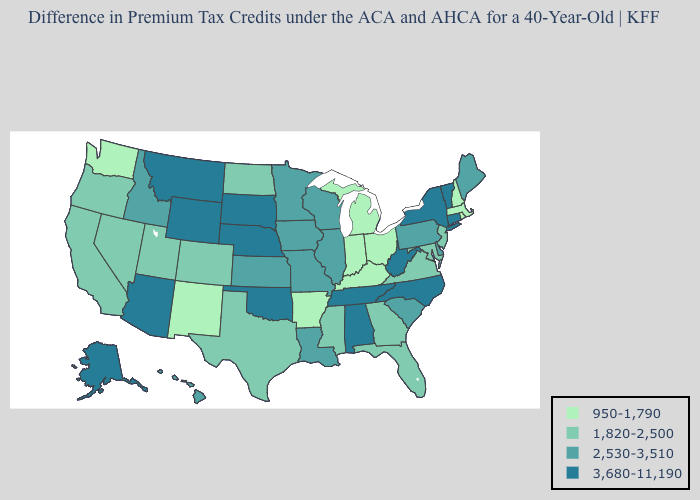Does the map have missing data?
Short answer required. No. What is the lowest value in states that border Maryland?
Give a very brief answer. 1,820-2,500. What is the value of South Carolina?
Answer briefly. 2,530-3,510. Does Iowa have a higher value than South Dakota?
Give a very brief answer. No. Does Rhode Island have the lowest value in the Northeast?
Be succinct. Yes. What is the value of Arizona?
Keep it brief. 3,680-11,190. Does Maryland have the lowest value in the USA?
Be succinct. No. What is the highest value in the USA?
Quick response, please. 3,680-11,190. Name the states that have a value in the range 3,680-11,190?
Concise answer only. Alabama, Alaska, Arizona, Connecticut, Montana, Nebraska, New York, North Carolina, Oklahoma, South Dakota, Tennessee, Vermont, West Virginia, Wyoming. What is the value of Minnesota?
Give a very brief answer. 2,530-3,510. What is the value of Kentucky?
Answer briefly. 950-1,790. Name the states that have a value in the range 2,530-3,510?
Answer briefly. Delaware, Hawaii, Idaho, Illinois, Iowa, Kansas, Louisiana, Maine, Minnesota, Missouri, Pennsylvania, South Carolina, Wisconsin. What is the lowest value in the USA?
Keep it brief. 950-1,790. What is the highest value in states that border Florida?
Give a very brief answer. 3,680-11,190. What is the highest value in the USA?
Give a very brief answer. 3,680-11,190. 